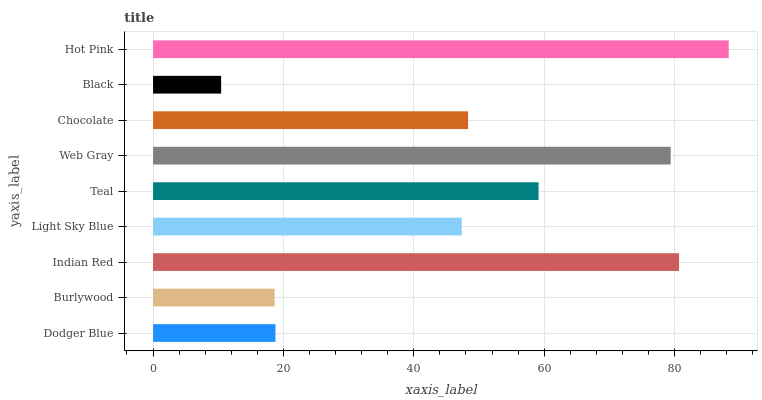Is Black the minimum?
Answer yes or no. Yes. Is Hot Pink the maximum?
Answer yes or no. Yes. Is Burlywood the minimum?
Answer yes or no. No. Is Burlywood the maximum?
Answer yes or no. No. Is Dodger Blue greater than Burlywood?
Answer yes or no. Yes. Is Burlywood less than Dodger Blue?
Answer yes or no. Yes. Is Burlywood greater than Dodger Blue?
Answer yes or no. No. Is Dodger Blue less than Burlywood?
Answer yes or no. No. Is Chocolate the high median?
Answer yes or no. Yes. Is Chocolate the low median?
Answer yes or no. Yes. Is Indian Red the high median?
Answer yes or no. No. Is Dodger Blue the low median?
Answer yes or no. No. 